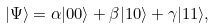<formula> <loc_0><loc_0><loc_500><loc_500>| \Psi \rangle = \alpha | 0 0 \rangle + \beta | 1 0 \rangle + \gamma | 1 1 \rangle ,</formula> 